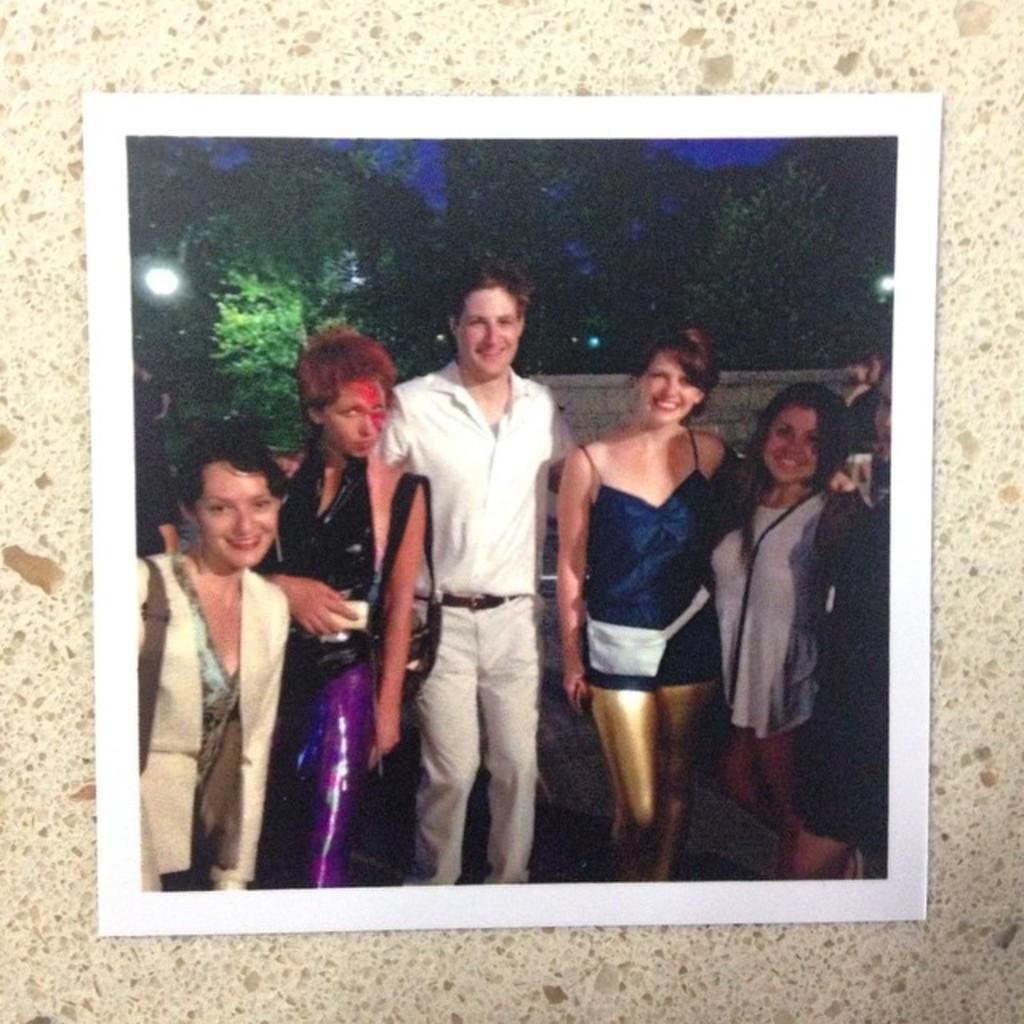In one or two sentences, can you explain what this image depicts? In this image I can see the cream and brown colored surface and on it I can see a photograph in which I can see few persons standing. In the background I can see the wall, few trees, few lights and the sky. 